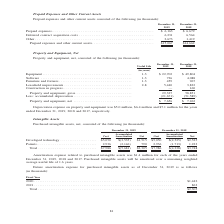According to A10 Networks's financial document, What is the depreciation expense on property and equipment as at December 31, 2017?  According to the financial document, $7.1 (in millions). The relevant text states: "y and equipment was $5.0 million, $6.4 million and $7.1 million for the years ended December 31, 2019, 2018 and 2017, respectively...." Also, What is the depreciation expense on property and equipment as at December 31, 2018? According to the financial document, $6.4 (in millions). The relevant text states: "xpense on property and equipment was $5.0 million, $6.4 million and $7.1 million for the years ended December 31, 2019, 2018 and 2017, respectively...." Also, What is the depreciation expense on property and equipment as at December 31, 2019? According to the financial document, $5.0 (in millions). The relevant text states: "Depreciation expense on property and equipment was $5.0 million, $6.4 million and $7.1 million for the years ended December 31, 2019, 2018 and 2017, respect..." Also, can you calculate: What is the ratio of net property and equipment in 2019? To answer this question, I need to perform calculations using the financial data. The calculation is: 7,656 thousand /(7,656 thousand + $5 million) , which equals 60.49 (percentage). This is based on the information: "Property and equipment, net . $ 7,656 $ 7,262 Property and equipment, net . $ 7,656 $ 7,262..." The key data points involved are: 5, 7,656. Also, can you calculate: What is the total depreciation expense on property and equipment from 2017 to 2019? Based on the calculation: 5.0+6.4+7.1, the result is 18.5 (in millions). This is based on the information: "preciation expense on property and equipment was $5.0 million, $6.4 million and $7.1 million for the years ended December 31, 2019, 2018 and 2017, respec and equipment was $5.0 million, $6.4 million a..." The key data points involved are: 5.0, 6.4, 7.1. Also, can you calculate: What is the total software value as at December 31, 2018 and 2019? Based on the calculation: 726 + 4,088 , the result is 4814 (in thousands). This is based on the information: "Equipment . 1-3 $ 22,702 $ 49,804 Software . 1-3 726 4,088 Furniture and fixtures . 1-3 459 967 Leasehold improvements . 2-8 5,440 3,832 Construction in ipment . 1-3 $ 22,702 $ 49,804 Software . 1-3 7..." The key data points involved are: 4,088, 726. 